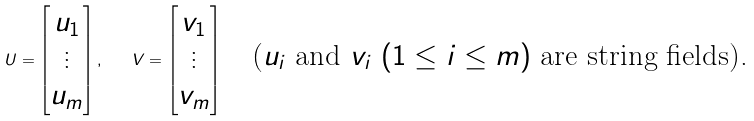Convert formula to latex. <formula><loc_0><loc_0><loc_500><loc_500>U = \begin{bmatrix} u _ { 1 } \\ \vdots \\ u _ { m } \\ \end{bmatrix} , \quad V = \begin{bmatrix} v _ { 1 } \\ \vdots \\ v _ { m } \\ \end{bmatrix} \quad \text {($u_{i}$ and $v_{i}$ $(1\leq i\leq m)$ are string fields).}</formula> 